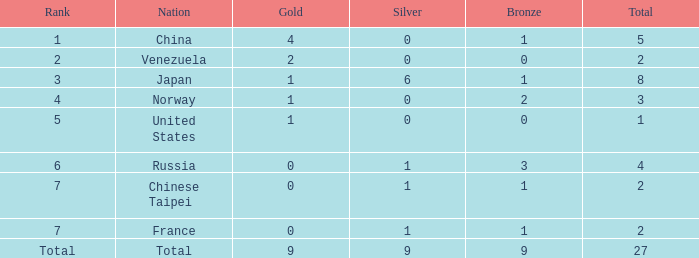When the rank is 2, what is the total amount? 2.0. 